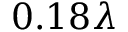Convert formula to latex. <formula><loc_0><loc_0><loc_500><loc_500>0 . 1 8 \lambda</formula> 